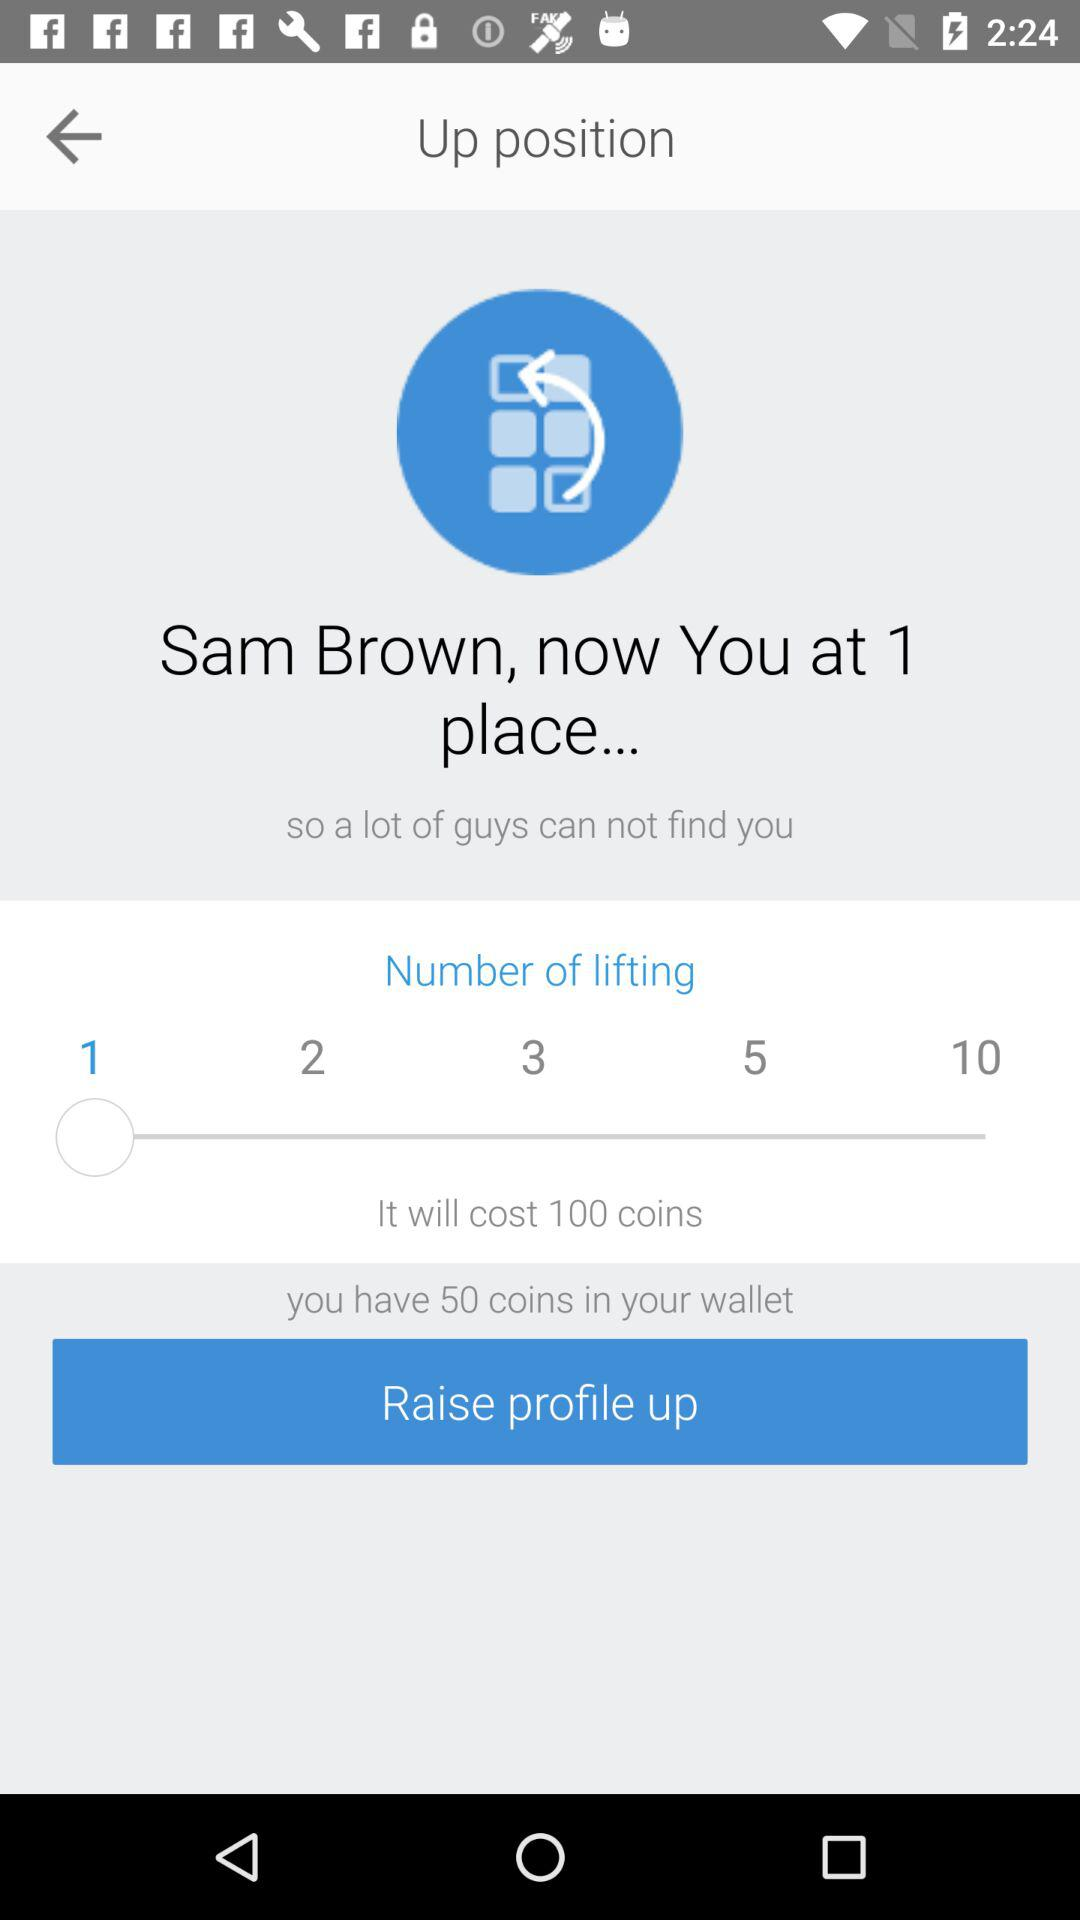At what place is Sam Brown? Sam Brown is at place 1. 